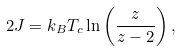<formula> <loc_0><loc_0><loc_500><loc_500>2 J = k _ { B } T _ { c } \ln \left ( \frac { z } { z - 2 } \right ) ,</formula> 